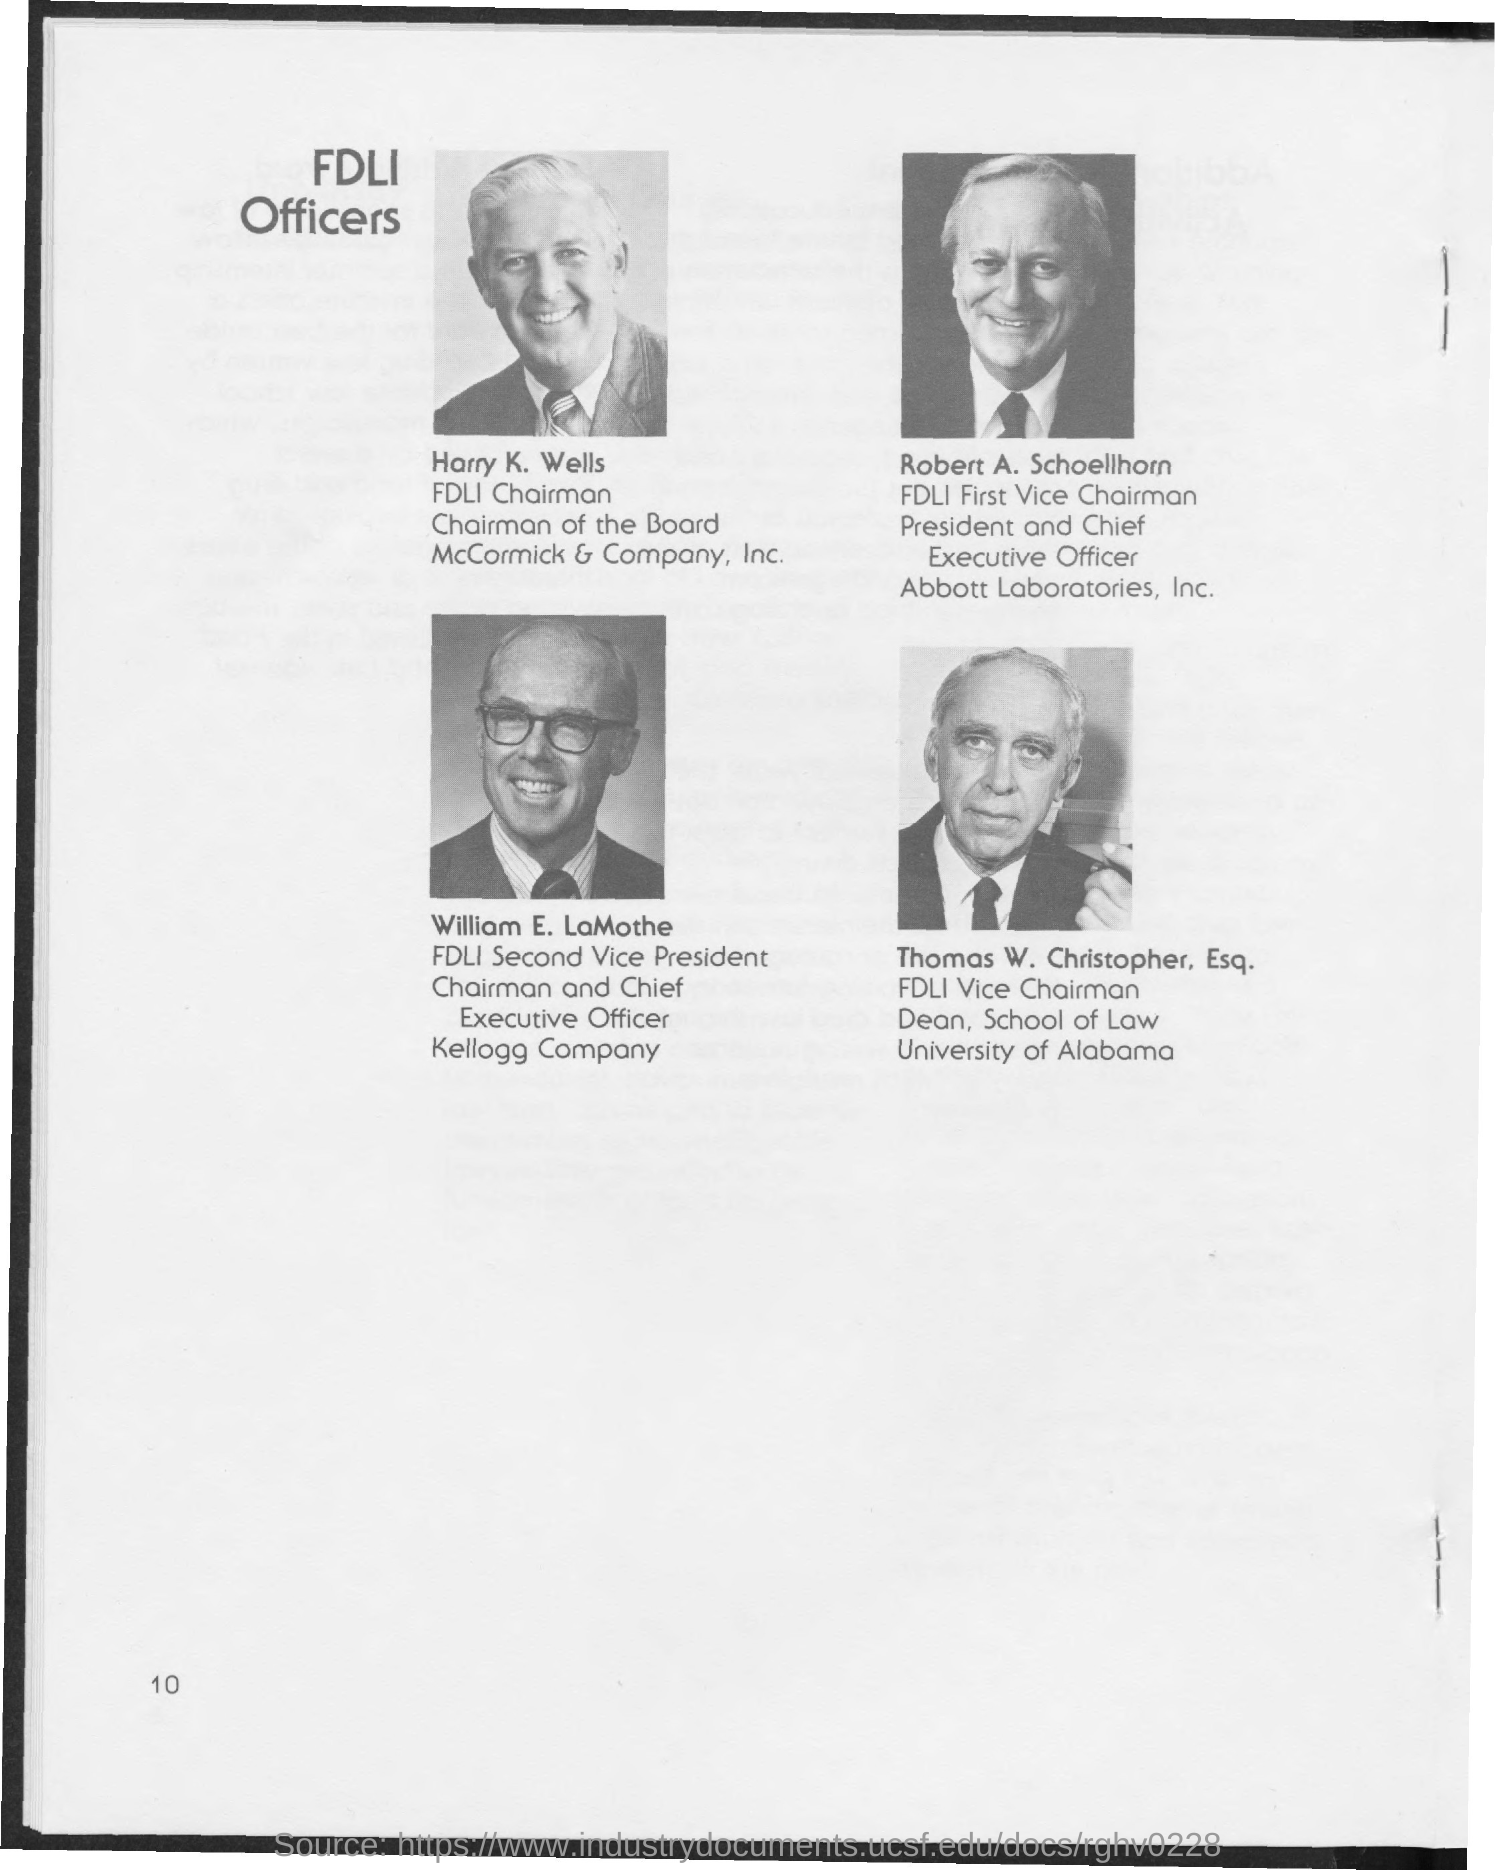What is the title of the document?
Provide a short and direct response. FDLI Officers. Who is the FDLI Chairman?
Ensure brevity in your answer.  Harry K. Wells. Who is the first vice-chairman of FDLI?
Your answer should be compact. Robert A. Schoellhorn. Who is the vice-chairman of FDLI?
Provide a short and direct response. Thomas W. Christopher, Esq. Who is the second vice-president of FDLI?
Offer a terse response. William E. LaMothe. What is the Page Number?
Your response must be concise. 10. 